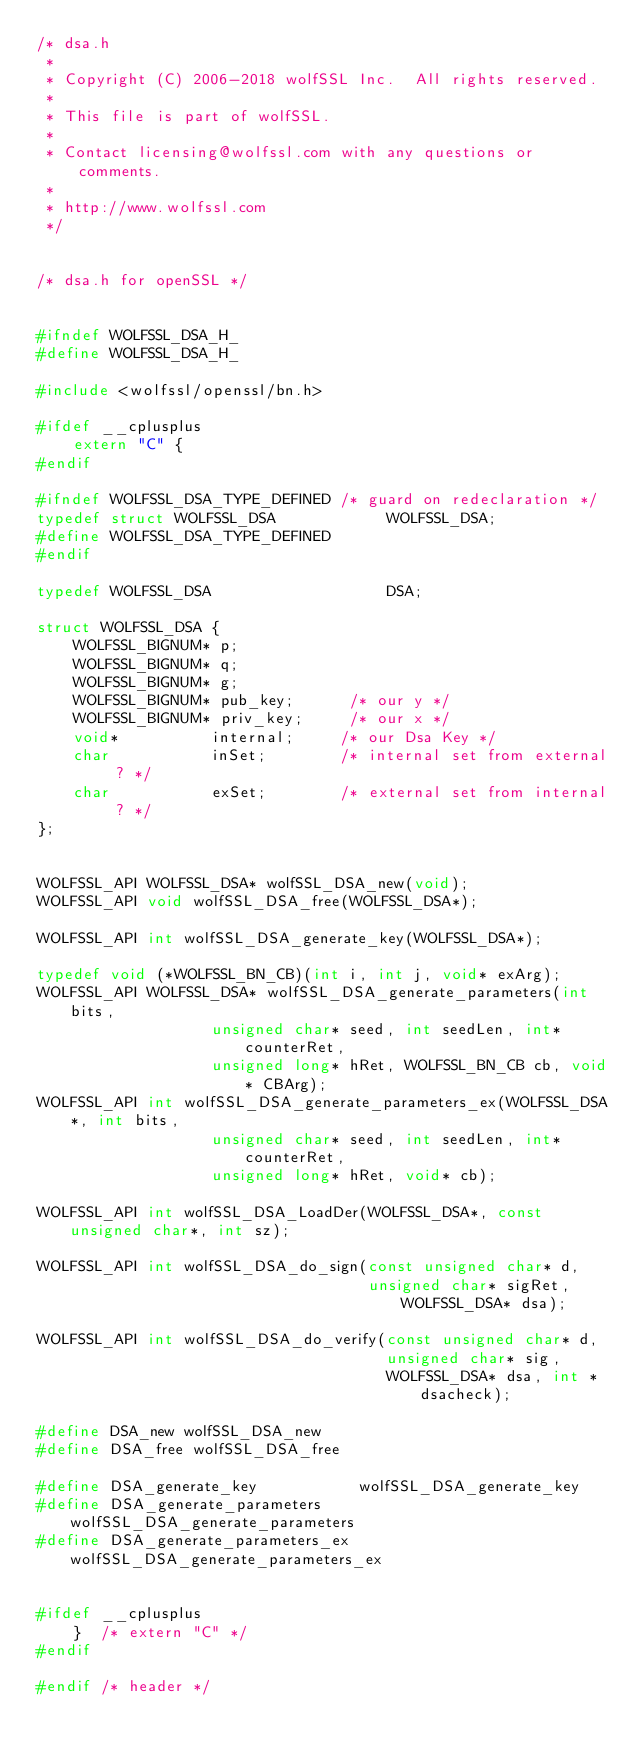Convert code to text. <code><loc_0><loc_0><loc_500><loc_500><_C_>/* dsa.h
 *
 * Copyright (C) 2006-2018 wolfSSL Inc.  All rights reserved.
 *
 * This file is part of wolfSSL.
 *
 * Contact licensing@wolfssl.com with any questions or comments.
 *
 * http://www.wolfssl.com
 */


/* dsa.h for openSSL */


#ifndef WOLFSSL_DSA_H_
#define WOLFSSL_DSA_H_

#include <wolfssl/openssl/bn.h>

#ifdef __cplusplus
    extern "C" {
#endif

#ifndef WOLFSSL_DSA_TYPE_DEFINED /* guard on redeclaration */
typedef struct WOLFSSL_DSA            WOLFSSL_DSA;
#define WOLFSSL_DSA_TYPE_DEFINED
#endif

typedef WOLFSSL_DSA                   DSA;

struct WOLFSSL_DSA {
    WOLFSSL_BIGNUM* p;
    WOLFSSL_BIGNUM* q;
    WOLFSSL_BIGNUM* g;
    WOLFSSL_BIGNUM* pub_key;      /* our y */
    WOLFSSL_BIGNUM* priv_key;     /* our x */
    void*          internal;     /* our Dsa Key */
    char           inSet;        /* internal set from external ? */
    char           exSet;        /* external set from internal ? */
};


WOLFSSL_API WOLFSSL_DSA* wolfSSL_DSA_new(void);
WOLFSSL_API void wolfSSL_DSA_free(WOLFSSL_DSA*);

WOLFSSL_API int wolfSSL_DSA_generate_key(WOLFSSL_DSA*);

typedef void (*WOLFSSL_BN_CB)(int i, int j, void* exArg);
WOLFSSL_API WOLFSSL_DSA* wolfSSL_DSA_generate_parameters(int bits,
                   unsigned char* seed, int seedLen, int* counterRet,
                   unsigned long* hRet, WOLFSSL_BN_CB cb, void* CBArg);
WOLFSSL_API int wolfSSL_DSA_generate_parameters_ex(WOLFSSL_DSA*, int bits,
                   unsigned char* seed, int seedLen, int* counterRet,
                   unsigned long* hRet, void* cb);

WOLFSSL_API int wolfSSL_DSA_LoadDer(WOLFSSL_DSA*, const unsigned char*, int sz);

WOLFSSL_API int wolfSSL_DSA_do_sign(const unsigned char* d,
                                    unsigned char* sigRet, WOLFSSL_DSA* dsa);

WOLFSSL_API int wolfSSL_DSA_do_verify(const unsigned char* d,
                                      unsigned char* sig,
                                      WOLFSSL_DSA* dsa, int *dsacheck);

#define DSA_new wolfSSL_DSA_new
#define DSA_free wolfSSL_DSA_free

#define DSA_generate_key           wolfSSL_DSA_generate_key
#define DSA_generate_parameters    wolfSSL_DSA_generate_parameters
#define DSA_generate_parameters_ex wolfSSL_DSA_generate_parameters_ex


#ifdef __cplusplus
    }  /* extern "C" */ 
#endif

#endif /* header */
</code> 